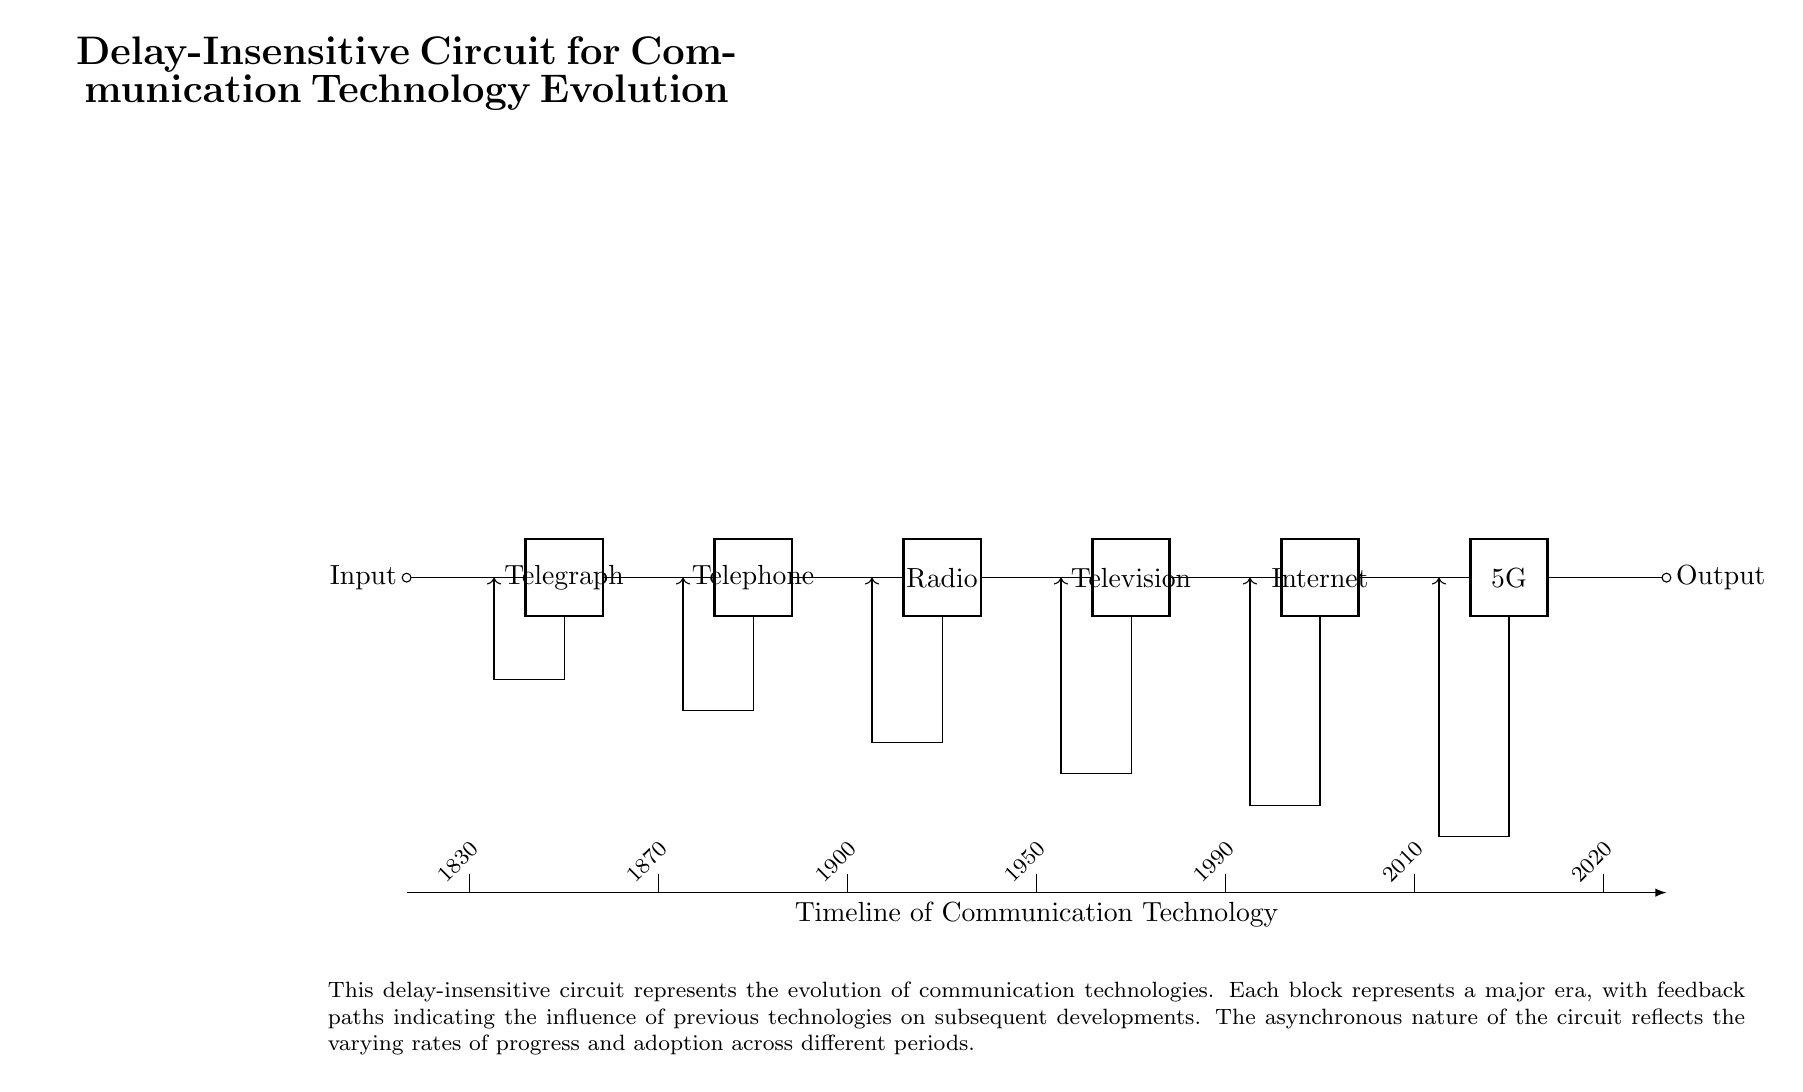What is the input to the circuit? The input to the circuit is labeled as "Input" on the left side of the diagram, indicating where the signal enters the circuit.
Answer: Input What is the output of the circuit? The output is indicated on the right side of the diagram with the label "Output," showing where the processed signal exits the circuit.
Answer: Output How many different communication technologies are represented in the circuit? The circuit includes six distinct two-port elements, each representing a key technology from the evolution of communication.
Answer: Six What year is associated with the invention of the telephone in the circuit? The diagram indicates the year 1870 directly beneath the telephone component, associating it with that particular technology's development.
Answer: 1870 What type of circuit is this? This is an asynchronous circuit since it is designed to operate without any global clock signal, demonstrating the various stages of communication technologies in a delay-insensitive manner.
Answer: Asynchronous How does the feedback path affect the circuit? The feedback paths demonstrate the historical influence of earlier technologies on the development of later ones, indicating a non-linear evolution of communication advancements.
Answer: Historical influence What year does the timeline end? The timeline represented in the diagram concludes with the year 2020, marking the latest significant advancement in communication technology as illustrated in the circuit.
Answer: 2020 